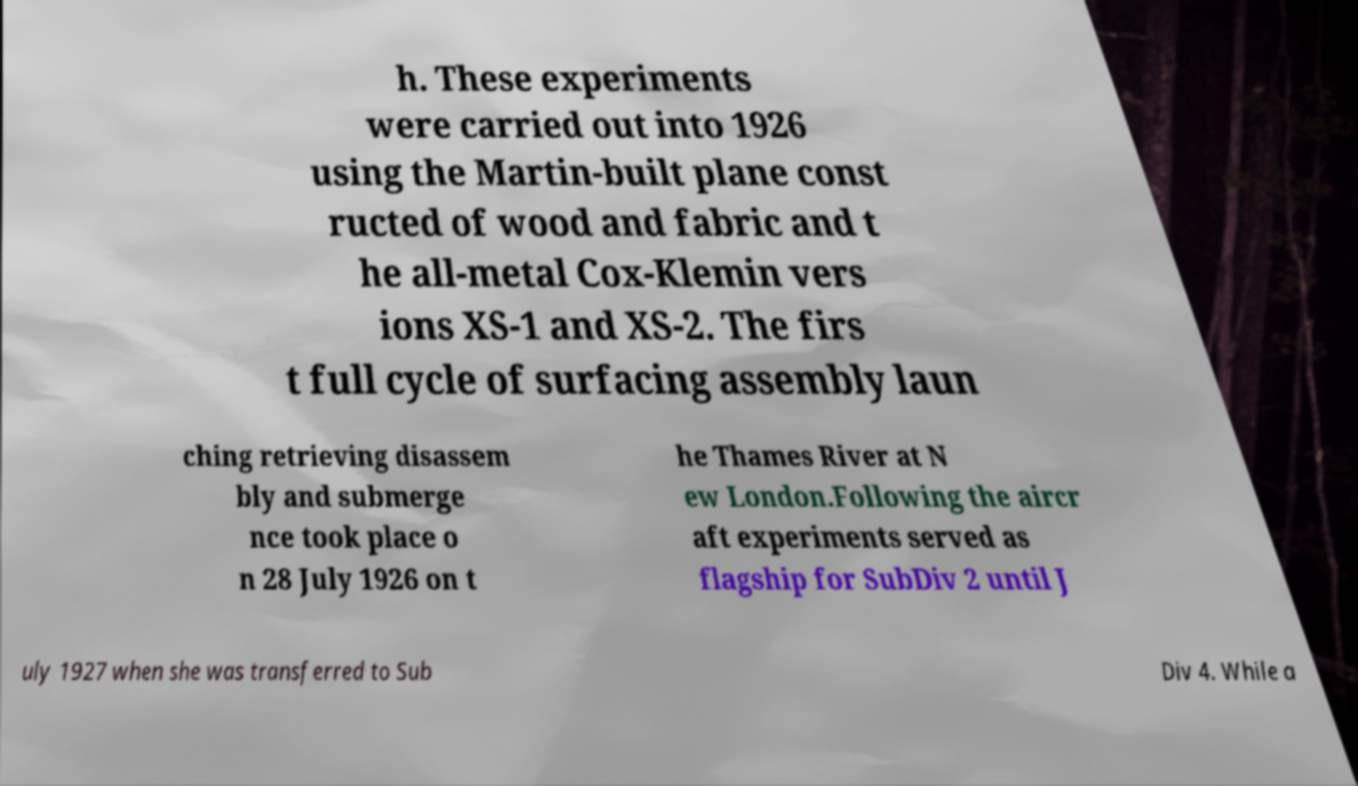Could you assist in decoding the text presented in this image and type it out clearly? h. These experiments were carried out into 1926 using the Martin-built plane const ructed of wood and fabric and t he all-metal Cox-Klemin vers ions XS-1 and XS-2. The firs t full cycle of surfacing assembly laun ching retrieving disassem bly and submerge nce took place o n 28 July 1926 on t he Thames River at N ew London.Following the aircr aft experiments served as flagship for SubDiv 2 until J uly 1927 when she was transferred to Sub Div 4. While a 